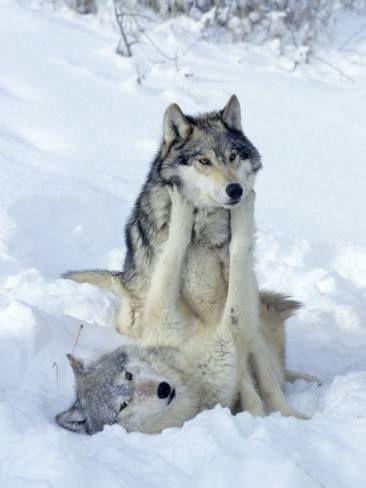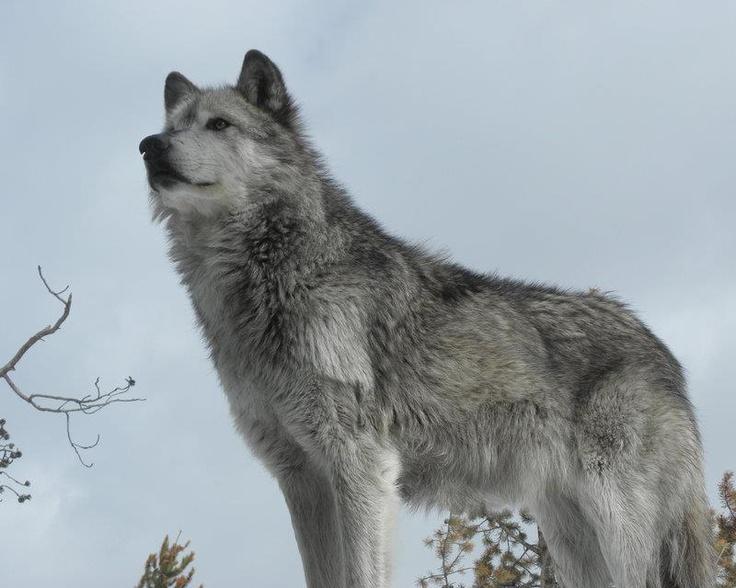The first image is the image on the left, the second image is the image on the right. Evaluate the accuracy of this statement regarding the images: "There are three wolves". Is it true? Answer yes or no. Yes. 